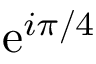<formula> <loc_0><loc_0><loc_500><loc_500>e ^ { i \pi / 4 }</formula> 